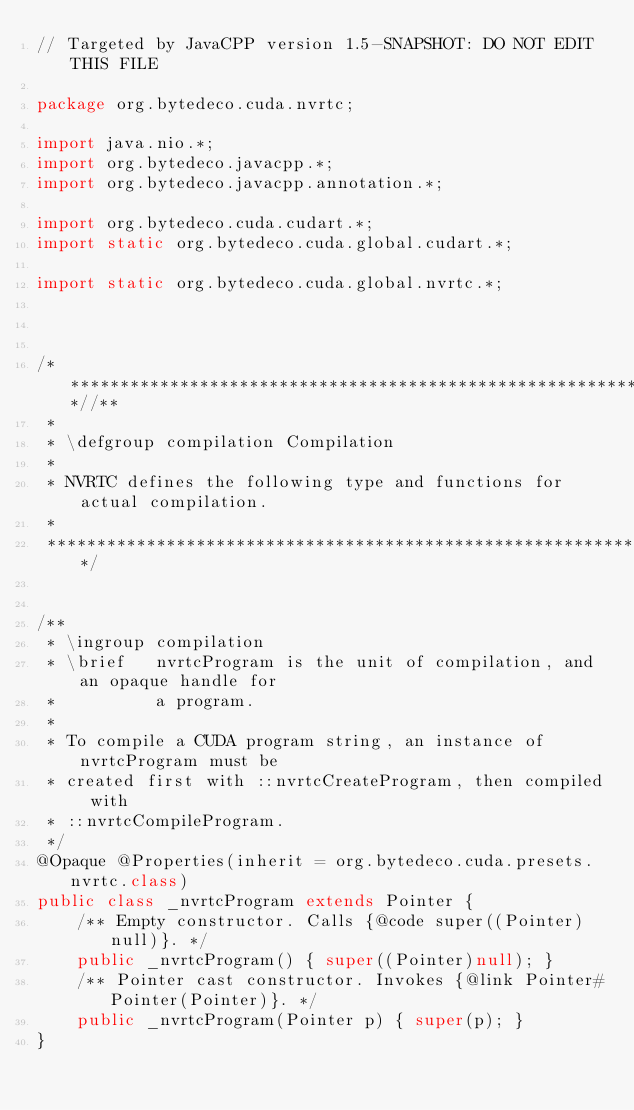<code> <loc_0><loc_0><loc_500><loc_500><_Java_>// Targeted by JavaCPP version 1.5-SNAPSHOT: DO NOT EDIT THIS FILE

package org.bytedeco.cuda.nvrtc;

import java.nio.*;
import org.bytedeco.javacpp.*;
import org.bytedeco.javacpp.annotation.*;

import org.bytedeco.cuda.cudart.*;
import static org.bytedeco.cuda.global.cudart.*;

import static org.bytedeco.cuda.global.nvrtc.*;



/*************************************************************************//**
 *
 * \defgroup compilation Compilation
 *
 * NVRTC defines the following type and functions for actual compilation.
 *
 ****************************************************************************/


/**
 * \ingroup compilation
 * \brief   nvrtcProgram is the unit of compilation, and an opaque handle for
 *          a program.
 *
 * To compile a CUDA program string, an instance of nvrtcProgram must be
 * created first with ::nvrtcCreateProgram, then compiled with
 * ::nvrtcCompileProgram.
 */
@Opaque @Properties(inherit = org.bytedeco.cuda.presets.nvrtc.class)
public class _nvrtcProgram extends Pointer {
    /** Empty constructor. Calls {@code super((Pointer)null)}. */
    public _nvrtcProgram() { super((Pointer)null); }
    /** Pointer cast constructor. Invokes {@link Pointer#Pointer(Pointer)}. */
    public _nvrtcProgram(Pointer p) { super(p); }
}
</code> 